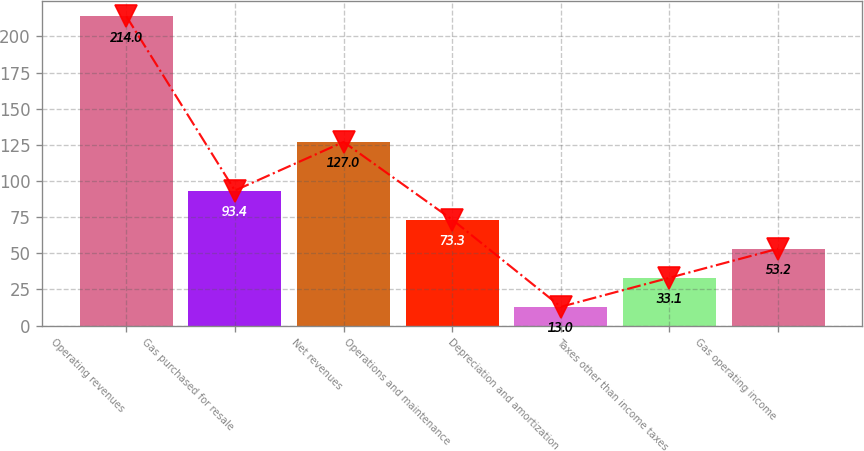Convert chart to OTSL. <chart><loc_0><loc_0><loc_500><loc_500><bar_chart><fcel>Operating revenues<fcel>Gas purchased for resale<fcel>Net revenues<fcel>Operations and maintenance<fcel>Depreciation and amortization<fcel>Taxes other than income taxes<fcel>Gas operating income<nl><fcel>214<fcel>93.4<fcel>127<fcel>73.3<fcel>13<fcel>33.1<fcel>53.2<nl></chart> 